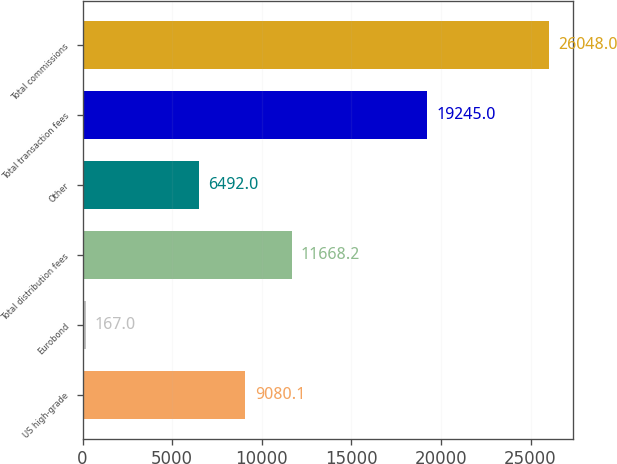Convert chart. <chart><loc_0><loc_0><loc_500><loc_500><bar_chart><fcel>US high-grade<fcel>Eurobond<fcel>Total distribution fees<fcel>Other<fcel>Total transaction fees<fcel>Total commissions<nl><fcel>9080.1<fcel>167<fcel>11668.2<fcel>6492<fcel>19245<fcel>26048<nl></chart> 